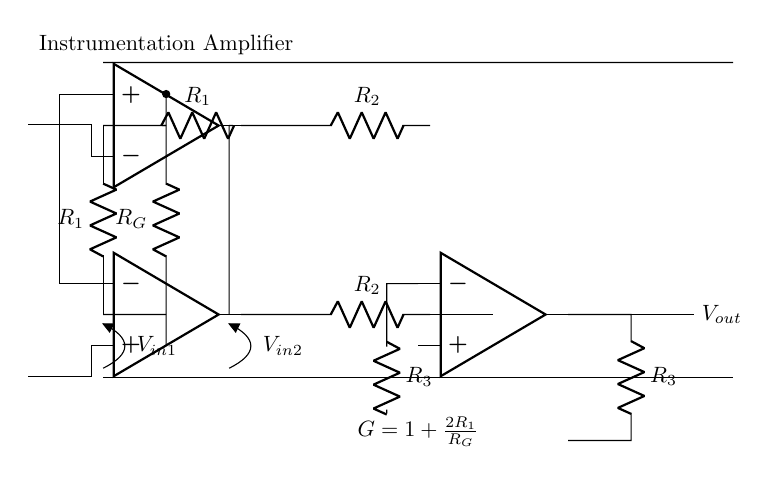What is the type of amplifier depicted? The circuit diagram displays an instrumentation amplifier, which is designed for precise measurements of small voltage differences. This is identified by the three operational amplifiers configured in a specific way to amplify a differential input voltage.
Answer: instrumentation amplifier How many resistors are present in the circuit? By counting the symbols in the diagram, there are a total of five resistors labeled R1, R2 (two of them), and R3, with one additional resistor labeled RG.
Answer: five What is the gain formula for this amplifier? The gain formula displayed in the diagram is G = 1 + (2R1/RG). This formula is written clearly below the circuit, which denotes how the gain relates to the resistor values used.
Answer: 1 + (2R1/RG) What does the symbol labeled Vout represent? The symbol Vout in the circuit indicates the output voltage of the instrumentation amplifier, which is the amplified version of the input voltage difference. This is found at the end of the output stage of the circuit.
Answer: output voltage What is the purpose of RG in this circuit? The resistor RG serves as the gain setting resistor in the instrumentation amplifier. It influences the overall gain of the circuit, as shown in the gain formula provided. This role is critical for adapting the amplifier to specific applications.
Answer: gain setting How many operational amplifiers are utilized in this circuit? The circuit uses three operational amplifiers, evident from the three op-amp symbols in the diagram. Each op-amp plays a different role in the input, middle, and output stages of amplification.
Answer: three What type of measurements is this circuit suitable for? This instrumentation amplifier is suitable for precise measurement of small voltage differences, as indicated by its design. It is particularly useful in applications requiring high accuracy and low noise, making it ideal for sensor signal amplification.
Answer: small voltage differences 